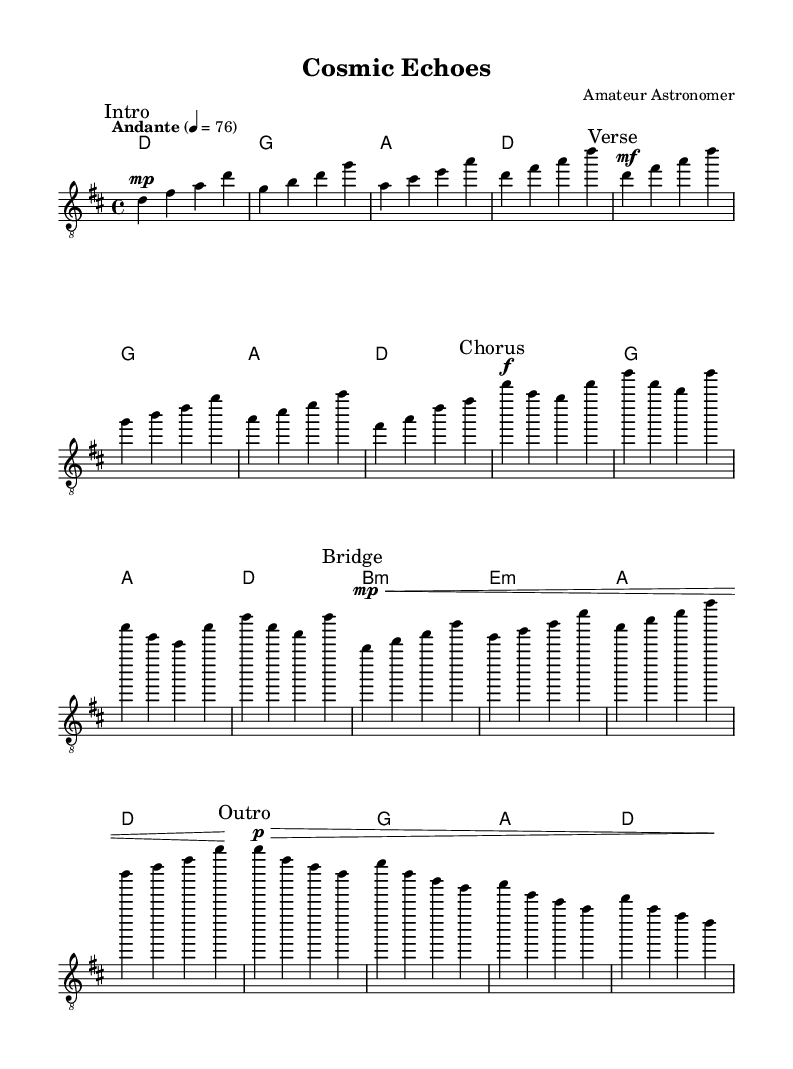What is the key signature of this music? The key signature is indicated by the sharps or flats placed at the beginning of the staff. Here, the music has two sharps (F# and C#), which indicates D major or B minor. The text indicates the use of D major.
Answer: D major What is the time signature of this music? The time signature is located at the beginning of the staff right after the key signature, represented by numbers. In this case, it shows '4/4', indicating four beats per measure.
Answer: 4/4 What is the tempo marking for this piece? The tempo marking is found at the start of the music, showing how fast or slow the piece should be played. Here, it reads "Andante" with a metronome marking of 76, indicating a moderate pace.
Answer: Andante 76 How many measures are in the Chorus section? To find the number of measures in the Chorus, count each segment between the bar lines in that section. The chorus has four distinct measures, as indicated by the separation of notes.
Answer: 4 What dynamics are used in the Verse section? The dynamics are marked in the music, indicating how loudly or softly to play. In the Verse section, the marking is 'mf,' which stands for 'mezzo-forte', meaning moderately loud.
Answer: mf Explain the purpose of the Bridge section in this piece. The Bridge is a contrasting section that provides variety and connects different parts of the song. It's typically softer as indicated by the 'mp' marking (mezzo-piano) to create a change in texture and build back into the Chorus. This soft dynamic enhances the transition.
Answer: To provide variety and transition 